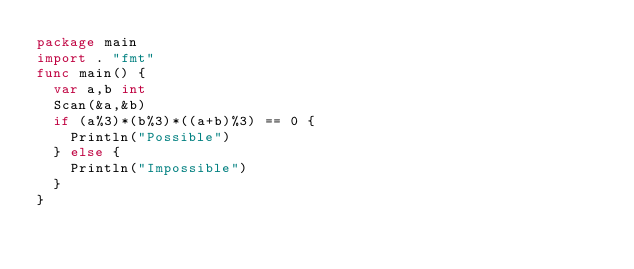<code> <loc_0><loc_0><loc_500><loc_500><_Go_>package main
import . "fmt"
func main() {
  var a,b int
  Scan(&a,&b)
  if (a%3)*(b%3)*((a+b)%3) == 0 {
    Println("Possible")
  } else {
    Println("Impossible")
  }
}</code> 